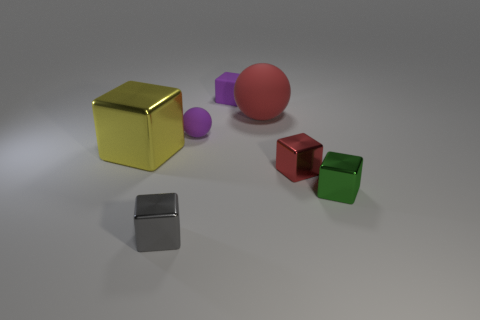What can you infer about the texture and material of the objects based on their appearance? The objects seem to have a variety of textures and materials. The metal ones appear smooth and reflective, suggesting a polished surface. The cubes seem satin-like with slightly diffused reflections, indicating a less reflective material with a bit of sheen, possibly painted wood or plastic. 